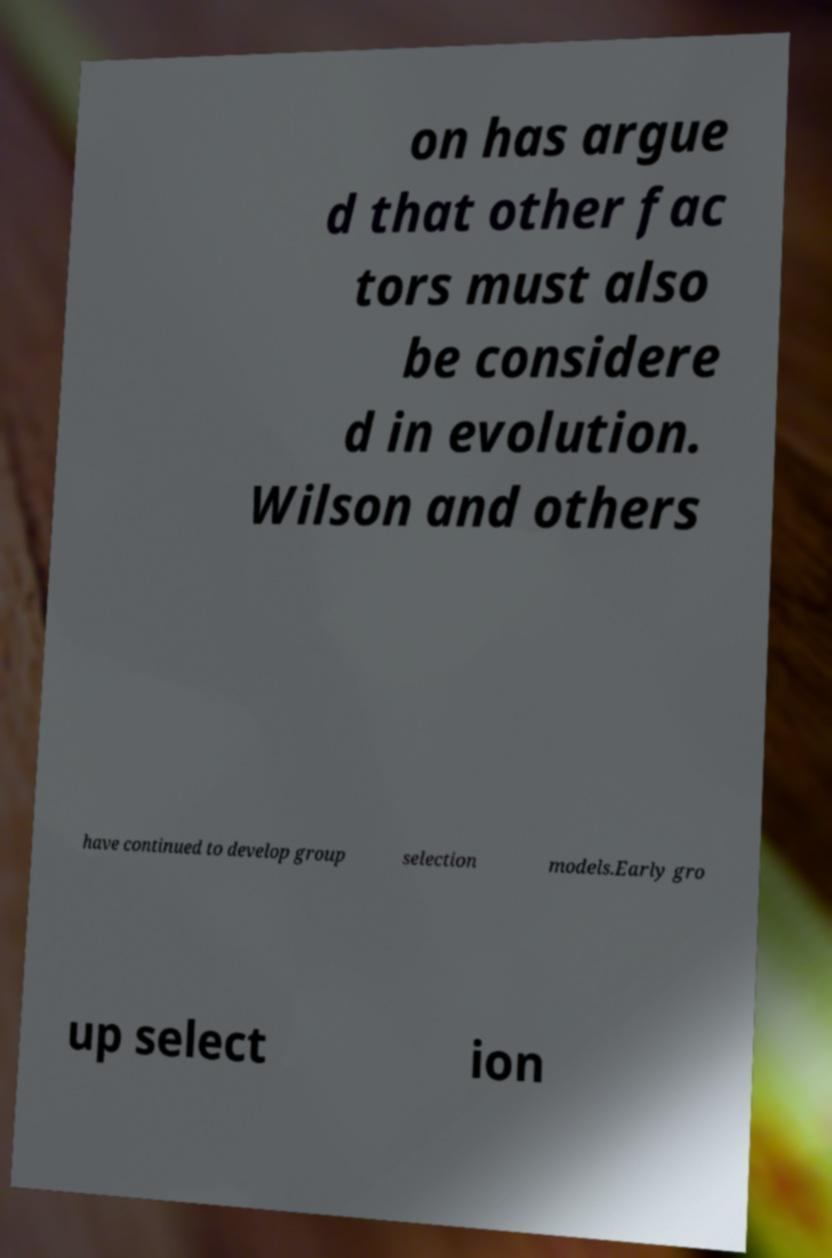Please read and relay the text visible in this image. What does it say? on has argue d that other fac tors must also be considere d in evolution. Wilson and others have continued to develop group selection models.Early gro up select ion 